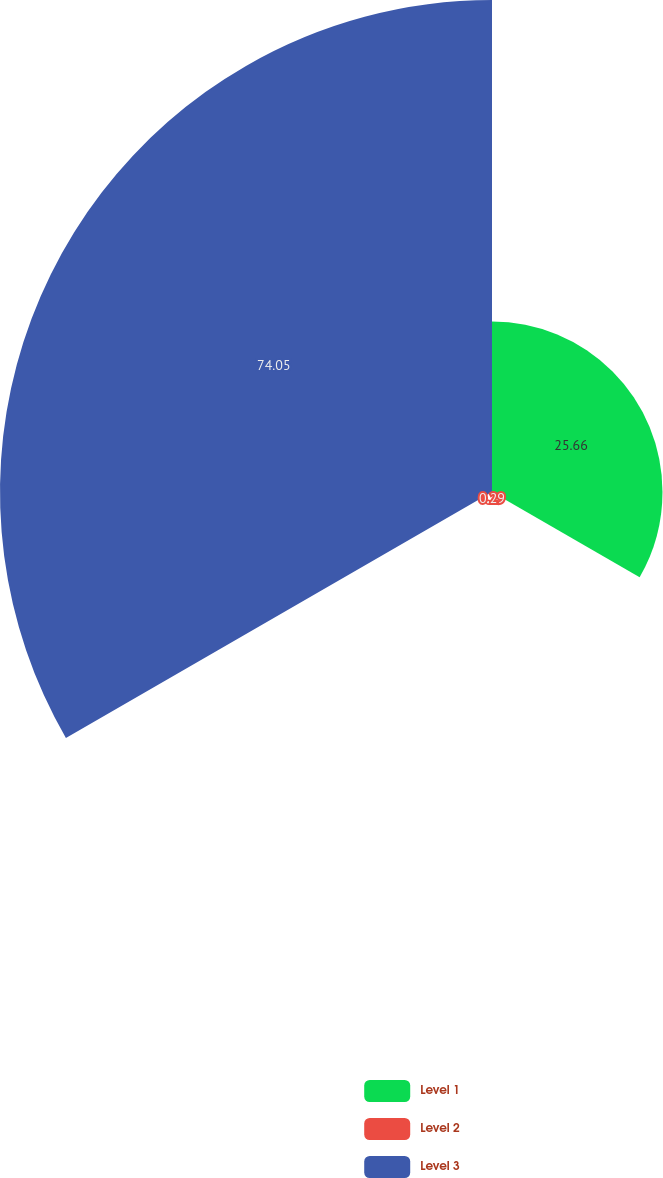Convert chart. <chart><loc_0><loc_0><loc_500><loc_500><pie_chart><fcel>Level 1<fcel>Level 2<fcel>Level 3<nl><fcel>25.66%<fcel>0.29%<fcel>74.05%<nl></chart> 